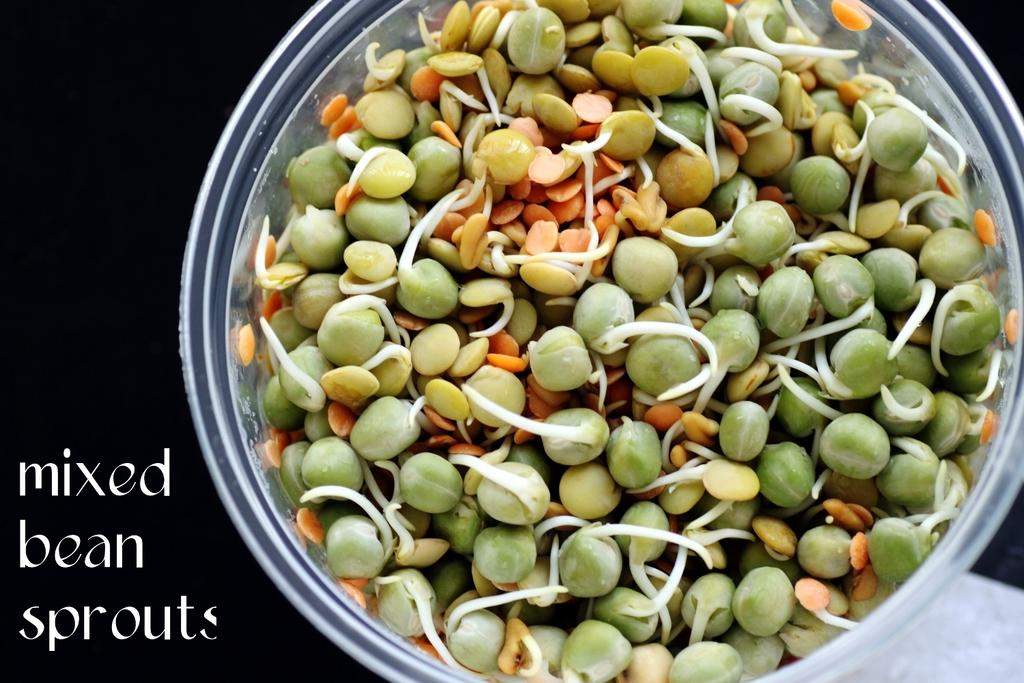What is in the bowl that is visible in the image? There are sprouts in a bowl in the image. What can be seen in the background of the image? The background of the image is dark. What else is visible in the image besides the sprouts and the dark background? There is some text visible in the image. What rhythm is the beggar tapping in the image? There is no beggar or rhythm present in the image; it features a bowl of sprouts and some text. 